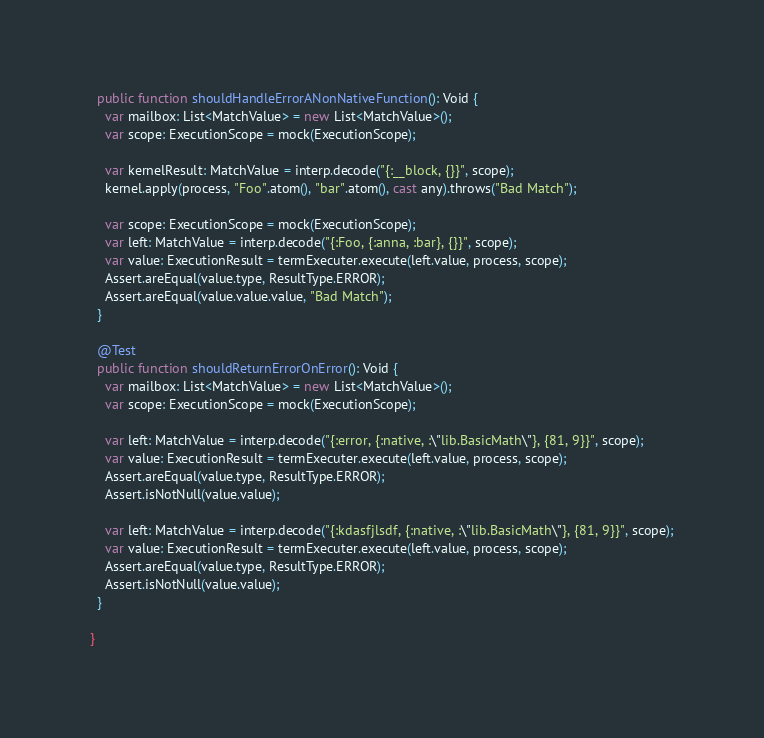<code> <loc_0><loc_0><loc_500><loc_500><_Haxe_>  public function shouldHandleErrorANonNativeFunction(): Void {
    var mailbox: List<MatchValue> = new List<MatchValue>();
    var scope: ExecutionScope = mock(ExecutionScope);

    var kernelResult: MatchValue = interp.decode("{:__block, {}}", scope);
    kernel.apply(process, "Foo".atom(), "bar".atom(), cast any).throws("Bad Match");

    var scope: ExecutionScope = mock(ExecutionScope);
    var left: MatchValue = interp.decode("{:Foo, {:anna, :bar}, {}}", scope);
    var value: ExecutionResult = termExecuter.execute(left.value, process, scope);
    Assert.areEqual(value.type, ResultType.ERROR);
    Assert.areEqual(value.value.value, "Bad Match");
  }

  @Test
  public function shouldReturnErrorOnError(): Void {
    var mailbox: List<MatchValue> = new List<MatchValue>();
    var scope: ExecutionScope = mock(ExecutionScope);

    var left: MatchValue = interp.decode("{:error, {:native, :\"lib.BasicMath\"}, {81, 9}}", scope);
    var value: ExecutionResult = termExecuter.execute(left.value, process, scope);
    Assert.areEqual(value.type, ResultType.ERROR);
    Assert.isNotNull(value.value);

    var left: MatchValue = interp.decode("{:kdasfjlsdf, {:native, :\"lib.BasicMath\"}, {81, 9}}", scope);
    var value: ExecutionResult = termExecuter.execute(left.value, process, scope);
    Assert.areEqual(value.type, ResultType.ERROR);
    Assert.isNotNull(value.value);
  }

}</code> 